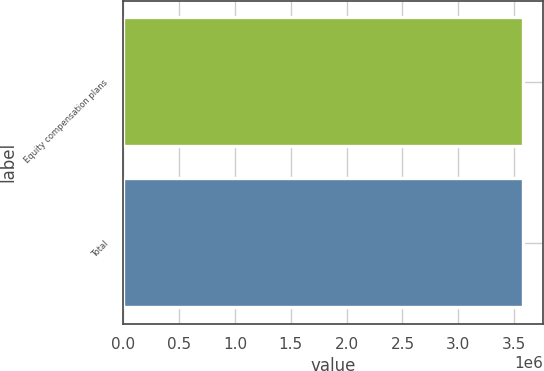Convert chart. <chart><loc_0><loc_0><loc_500><loc_500><bar_chart><fcel>Equity compensation plans<fcel>Total<nl><fcel>3.57751e+06<fcel>3.57751e+06<nl></chart> 